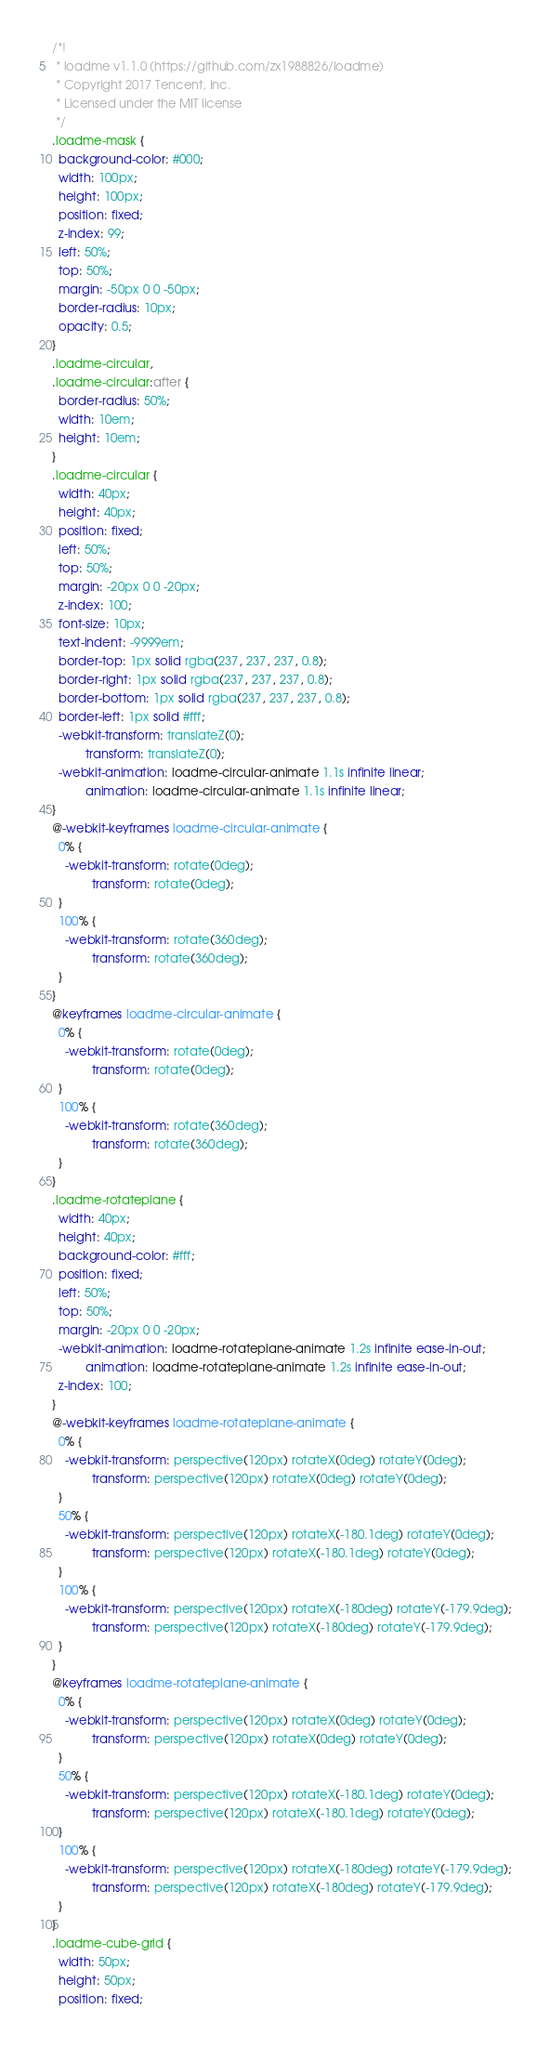<code> <loc_0><loc_0><loc_500><loc_500><_CSS_>/*!
 * loadme v1.1.0 (https://github.com/zx1988826/loadme)
 * Copyright 2017 Tencent, Inc.
 * Licensed under the MIT license
 */
.loadme-mask {
  background-color: #000;
  width: 100px;
  height: 100px;
  position: fixed;
  z-index: 99;
  left: 50%;
  top: 50%;
  margin: -50px 0 0 -50px;
  border-radius: 10px;
  opacity: 0.5;
}
.loadme-circular,
.loadme-circular:after {
  border-radius: 50%;
  width: 10em;
  height: 10em;
}
.loadme-circular {
  width: 40px;
  height: 40px;
  position: fixed;
  left: 50%;
  top: 50%;
  margin: -20px 0 0 -20px;
  z-index: 100;
  font-size: 10px;
  text-indent: -9999em;
  border-top: 1px solid rgba(237, 237, 237, 0.8);
  border-right: 1px solid rgba(237, 237, 237, 0.8);
  border-bottom: 1px solid rgba(237, 237, 237, 0.8);
  border-left: 1px solid #fff;
  -webkit-transform: translateZ(0);
          transform: translateZ(0);
  -webkit-animation: loadme-circular-animate 1.1s infinite linear;
          animation: loadme-circular-animate 1.1s infinite linear;
}
@-webkit-keyframes loadme-circular-animate {
  0% {
    -webkit-transform: rotate(0deg);
            transform: rotate(0deg);
  }
  100% {
    -webkit-transform: rotate(360deg);
            transform: rotate(360deg);
  }
}
@keyframes loadme-circular-animate {
  0% {
    -webkit-transform: rotate(0deg);
            transform: rotate(0deg);
  }
  100% {
    -webkit-transform: rotate(360deg);
            transform: rotate(360deg);
  }
}
.loadme-rotateplane {
  width: 40px;
  height: 40px;
  background-color: #fff;
  position: fixed;
  left: 50%;
  top: 50%;
  margin: -20px 0 0 -20px;
  -webkit-animation: loadme-rotateplane-animate 1.2s infinite ease-in-out;
          animation: loadme-rotateplane-animate 1.2s infinite ease-in-out;
  z-index: 100;
}
@-webkit-keyframes loadme-rotateplane-animate {
  0% {
    -webkit-transform: perspective(120px) rotateX(0deg) rotateY(0deg);
            transform: perspective(120px) rotateX(0deg) rotateY(0deg);
  }
  50% {
    -webkit-transform: perspective(120px) rotateX(-180.1deg) rotateY(0deg);
            transform: perspective(120px) rotateX(-180.1deg) rotateY(0deg);
  }
  100% {
    -webkit-transform: perspective(120px) rotateX(-180deg) rotateY(-179.9deg);
            transform: perspective(120px) rotateX(-180deg) rotateY(-179.9deg);
  }
}
@keyframes loadme-rotateplane-animate {
  0% {
    -webkit-transform: perspective(120px) rotateX(0deg) rotateY(0deg);
            transform: perspective(120px) rotateX(0deg) rotateY(0deg);
  }
  50% {
    -webkit-transform: perspective(120px) rotateX(-180.1deg) rotateY(0deg);
            transform: perspective(120px) rotateX(-180.1deg) rotateY(0deg);
  }
  100% {
    -webkit-transform: perspective(120px) rotateX(-180deg) rotateY(-179.9deg);
            transform: perspective(120px) rotateX(-180deg) rotateY(-179.9deg);
  }
}
.loadme-cube-grid {
  width: 50px;
  height: 50px;
  position: fixed;</code> 